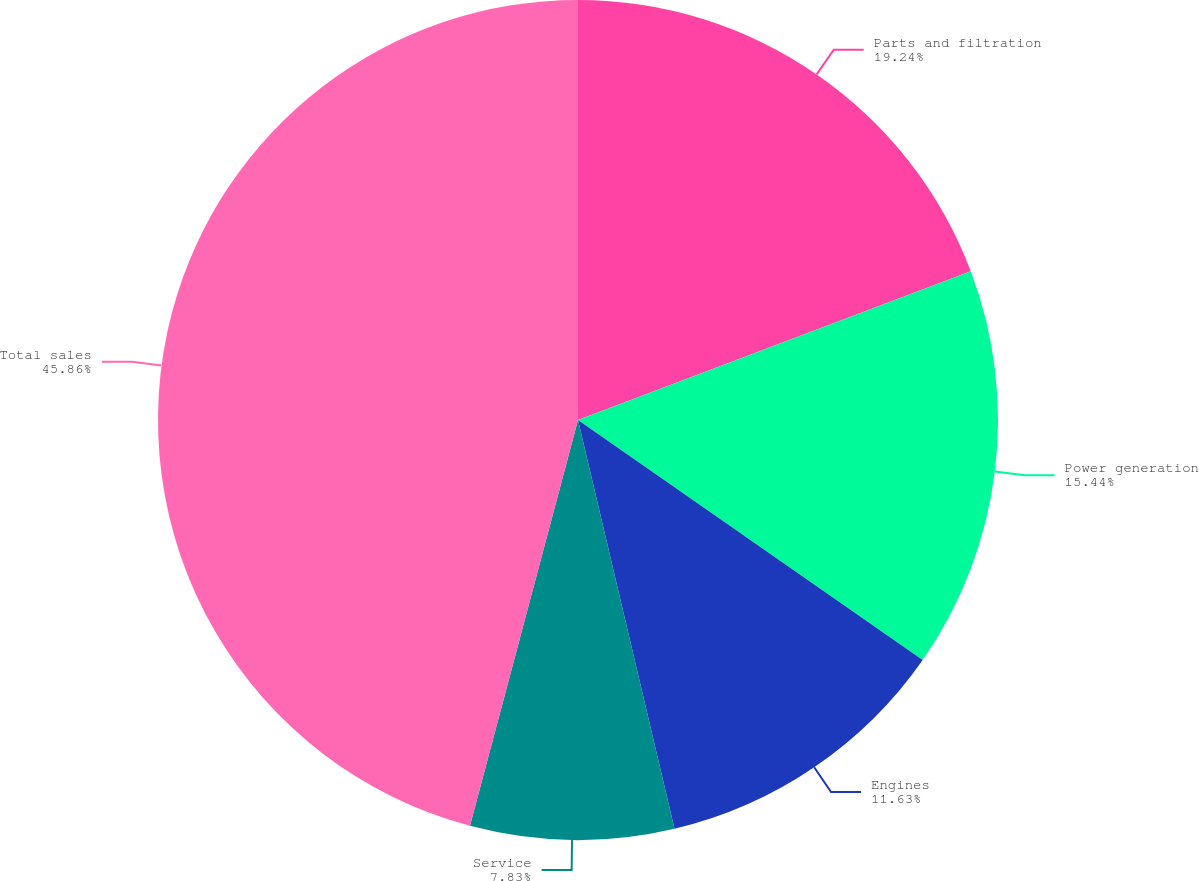Convert chart. <chart><loc_0><loc_0><loc_500><loc_500><pie_chart><fcel>Parts and filtration<fcel>Power generation<fcel>Engines<fcel>Service<fcel>Total sales<nl><fcel>19.24%<fcel>15.44%<fcel>11.63%<fcel>7.83%<fcel>45.86%<nl></chart> 